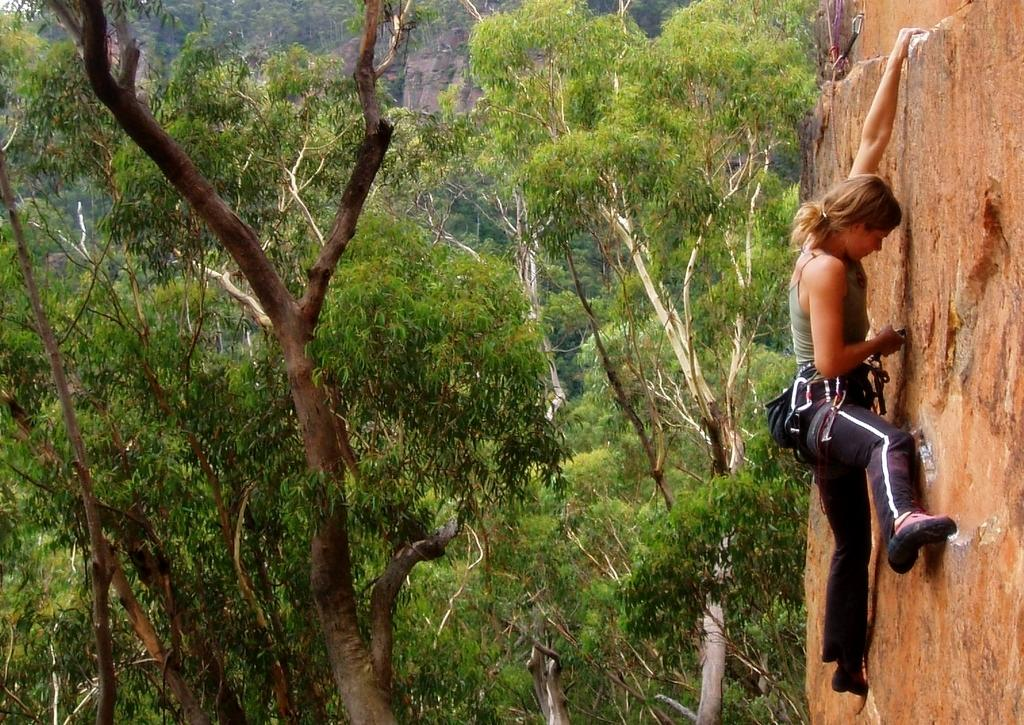Who is the main subject in the image? There is a woman in the image. What is the woman doing in the image? The woman is climbing a rock. What can be seen in the background of the image? There are trees visible in the image. What type of turkey can be seen in the image? There is no turkey present in the image. What is the woman using to rake leaves in the image? The woman is not raking leaves in the image; she is climbing a rock. 